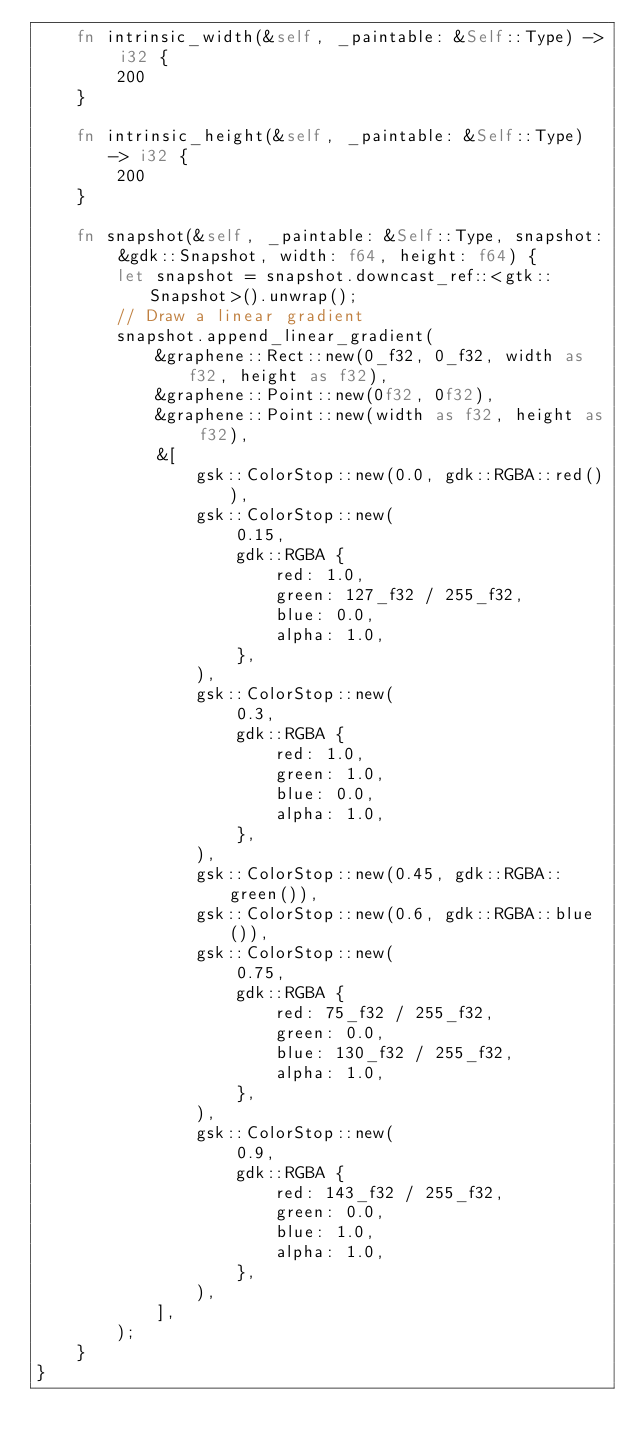Convert code to text. <code><loc_0><loc_0><loc_500><loc_500><_Rust_>    fn intrinsic_width(&self, _paintable: &Self::Type) -> i32 {
        200
    }

    fn intrinsic_height(&self, _paintable: &Self::Type) -> i32 {
        200
    }

    fn snapshot(&self, _paintable: &Self::Type, snapshot: &gdk::Snapshot, width: f64, height: f64) {
        let snapshot = snapshot.downcast_ref::<gtk::Snapshot>().unwrap();
        // Draw a linear gradient
        snapshot.append_linear_gradient(
            &graphene::Rect::new(0_f32, 0_f32, width as f32, height as f32),
            &graphene::Point::new(0f32, 0f32),
            &graphene::Point::new(width as f32, height as f32),
            &[
                gsk::ColorStop::new(0.0, gdk::RGBA::red()),
                gsk::ColorStop::new(
                    0.15,
                    gdk::RGBA {
                        red: 1.0,
                        green: 127_f32 / 255_f32,
                        blue: 0.0,
                        alpha: 1.0,
                    },
                ),
                gsk::ColorStop::new(
                    0.3,
                    gdk::RGBA {
                        red: 1.0,
                        green: 1.0,
                        blue: 0.0,
                        alpha: 1.0,
                    },
                ),
                gsk::ColorStop::new(0.45, gdk::RGBA::green()),
                gsk::ColorStop::new(0.6, gdk::RGBA::blue()),
                gsk::ColorStop::new(
                    0.75,
                    gdk::RGBA {
                        red: 75_f32 / 255_f32,
                        green: 0.0,
                        blue: 130_f32 / 255_f32,
                        alpha: 1.0,
                    },
                ),
                gsk::ColorStop::new(
                    0.9,
                    gdk::RGBA {
                        red: 143_f32 / 255_f32,
                        green: 0.0,
                        blue: 1.0,
                        alpha: 1.0,
                    },
                ),
            ],
        );
    }
}
</code> 